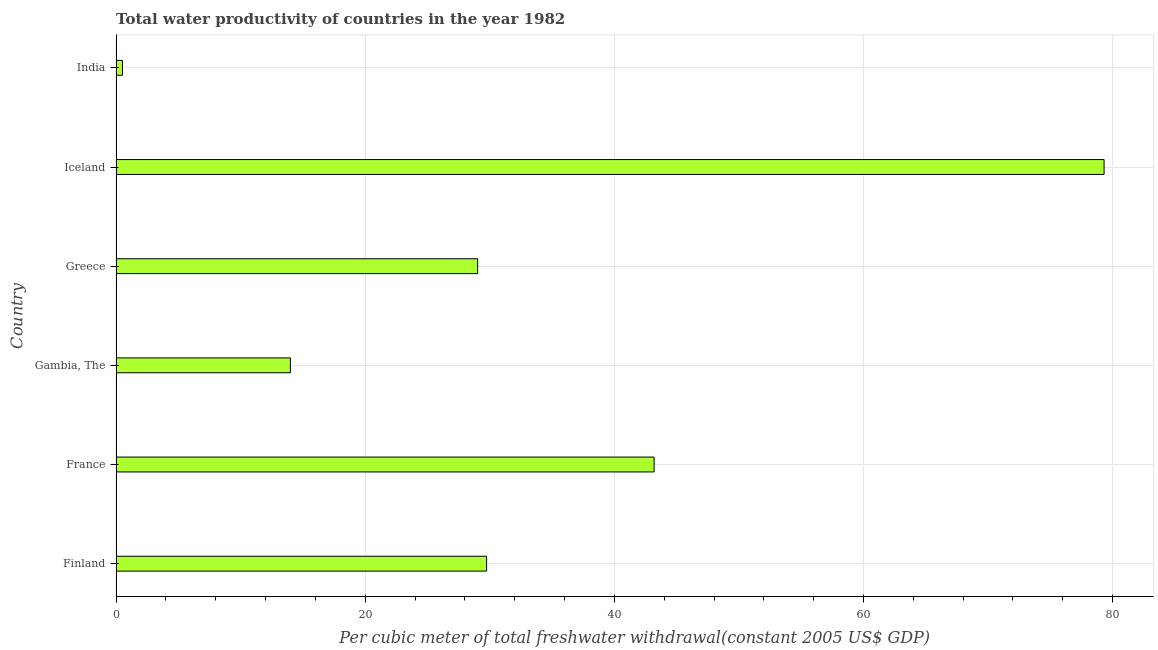Does the graph contain any zero values?
Offer a very short reply. No. Does the graph contain grids?
Your answer should be compact. Yes. What is the title of the graph?
Provide a succinct answer. Total water productivity of countries in the year 1982. What is the label or title of the X-axis?
Ensure brevity in your answer.  Per cubic meter of total freshwater withdrawal(constant 2005 US$ GDP). What is the total water productivity in Iceland?
Offer a very short reply. 79.31. Across all countries, what is the maximum total water productivity?
Offer a very short reply. 79.31. Across all countries, what is the minimum total water productivity?
Provide a succinct answer. 0.51. In which country was the total water productivity minimum?
Keep it short and to the point. India. What is the sum of the total water productivity?
Offer a very short reply. 195.77. What is the difference between the total water productivity in Gambia, The and Iceland?
Your answer should be compact. -65.32. What is the average total water productivity per country?
Make the answer very short. 32.63. What is the median total water productivity?
Offer a very short reply. 29.38. In how many countries, is the total water productivity greater than 64 US$?
Your response must be concise. 1. What is the ratio of the total water productivity in Gambia, The to that in Iceland?
Your answer should be compact. 0.18. Is the total water productivity in France less than that in Greece?
Ensure brevity in your answer.  No. What is the difference between the highest and the second highest total water productivity?
Give a very brief answer. 36.13. Is the sum of the total water productivity in Gambia, The and India greater than the maximum total water productivity across all countries?
Offer a very short reply. No. What is the difference between the highest and the lowest total water productivity?
Provide a short and direct response. 78.8. In how many countries, is the total water productivity greater than the average total water productivity taken over all countries?
Your response must be concise. 2. How many bars are there?
Your answer should be compact. 6. Are all the bars in the graph horizontal?
Offer a terse response. Yes. Are the values on the major ticks of X-axis written in scientific E-notation?
Keep it short and to the point. No. What is the Per cubic meter of total freshwater withdrawal(constant 2005 US$ GDP) of Finland?
Give a very brief answer. 29.74. What is the Per cubic meter of total freshwater withdrawal(constant 2005 US$ GDP) in France?
Ensure brevity in your answer.  43.19. What is the Per cubic meter of total freshwater withdrawal(constant 2005 US$ GDP) of Gambia, The?
Offer a very short reply. 13.99. What is the Per cubic meter of total freshwater withdrawal(constant 2005 US$ GDP) of Greece?
Your answer should be very brief. 29.02. What is the Per cubic meter of total freshwater withdrawal(constant 2005 US$ GDP) of Iceland?
Give a very brief answer. 79.31. What is the Per cubic meter of total freshwater withdrawal(constant 2005 US$ GDP) of India?
Provide a short and direct response. 0.51. What is the difference between the Per cubic meter of total freshwater withdrawal(constant 2005 US$ GDP) in Finland and France?
Keep it short and to the point. -13.45. What is the difference between the Per cubic meter of total freshwater withdrawal(constant 2005 US$ GDP) in Finland and Gambia, The?
Make the answer very short. 15.75. What is the difference between the Per cubic meter of total freshwater withdrawal(constant 2005 US$ GDP) in Finland and Greece?
Provide a succinct answer. 0.72. What is the difference between the Per cubic meter of total freshwater withdrawal(constant 2005 US$ GDP) in Finland and Iceland?
Offer a terse response. -49.57. What is the difference between the Per cubic meter of total freshwater withdrawal(constant 2005 US$ GDP) in Finland and India?
Give a very brief answer. 29.23. What is the difference between the Per cubic meter of total freshwater withdrawal(constant 2005 US$ GDP) in France and Gambia, The?
Offer a terse response. 29.2. What is the difference between the Per cubic meter of total freshwater withdrawal(constant 2005 US$ GDP) in France and Greece?
Ensure brevity in your answer.  14.16. What is the difference between the Per cubic meter of total freshwater withdrawal(constant 2005 US$ GDP) in France and Iceland?
Offer a very short reply. -36.13. What is the difference between the Per cubic meter of total freshwater withdrawal(constant 2005 US$ GDP) in France and India?
Your answer should be compact. 42.68. What is the difference between the Per cubic meter of total freshwater withdrawal(constant 2005 US$ GDP) in Gambia, The and Greece?
Your response must be concise. -15.03. What is the difference between the Per cubic meter of total freshwater withdrawal(constant 2005 US$ GDP) in Gambia, The and Iceland?
Your response must be concise. -65.32. What is the difference between the Per cubic meter of total freshwater withdrawal(constant 2005 US$ GDP) in Gambia, The and India?
Provide a short and direct response. 13.48. What is the difference between the Per cubic meter of total freshwater withdrawal(constant 2005 US$ GDP) in Greece and Iceland?
Offer a terse response. -50.29. What is the difference between the Per cubic meter of total freshwater withdrawal(constant 2005 US$ GDP) in Greece and India?
Your response must be concise. 28.51. What is the difference between the Per cubic meter of total freshwater withdrawal(constant 2005 US$ GDP) in Iceland and India?
Your response must be concise. 78.8. What is the ratio of the Per cubic meter of total freshwater withdrawal(constant 2005 US$ GDP) in Finland to that in France?
Your response must be concise. 0.69. What is the ratio of the Per cubic meter of total freshwater withdrawal(constant 2005 US$ GDP) in Finland to that in Gambia, The?
Ensure brevity in your answer.  2.13. What is the ratio of the Per cubic meter of total freshwater withdrawal(constant 2005 US$ GDP) in Finland to that in Greece?
Your response must be concise. 1.02. What is the ratio of the Per cubic meter of total freshwater withdrawal(constant 2005 US$ GDP) in Finland to that in India?
Offer a terse response. 58.26. What is the ratio of the Per cubic meter of total freshwater withdrawal(constant 2005 US$ GDP) in France to that in Gambia, The?
Your answer should be very brief. 3.09. What is the ratio of the Per cubic meter of total freshwater withdrawal(constant 2005 US$ GDP) in France to that in Greece?
Make the answer very short. 1.49. What is the ratio of the Per cubic meter of total freshwater withdrawal(constant 2005 US$ GDP) in France to that in Iceland?
Provide a short and direct response. 0.55. What is the ratio of the Per cubic meter of total freshwater withdrawal(constant 2005 US$ GDP) in France to that in India?
Offer a very short reply. 84.61. What is the ratio of the Per cubic meter of total freshwater withdrawal(constant 2005 US$ GDP) in Gambia, The to that in Greece?
Make the answer very short. 0.48. What is the ratio of the Per cubic meter of total freshwater withdrawal(constant 2005 US$ GDP) in Gambia, The to that in Iceland?
Offer a terse response. 0.18. What is the ratio of the Per cubic meter of total freshwater withdrawal(constant 2005 US$ GDP) in Gambia, The to that in India?
Keep it short and to the point. 27.41. What is the ratio of the Per cubic meter of total freshwater withdrawal(constant 2005 US$ GDP) in Greece to that in Iceland?
Your response must be concise. 0.37. What is the ratio of the Per cubic meter of total freshwater withdrawal(constant 2005 US$ GDP) in Greece to that in India?
Your answer should be compact. 56.86. What is the ratio of the Per cubic meter of total freshwater withdrawal(constant 2005 US$ GDP) in Iceland to that in India?
Make the answer very short. 155.38. 